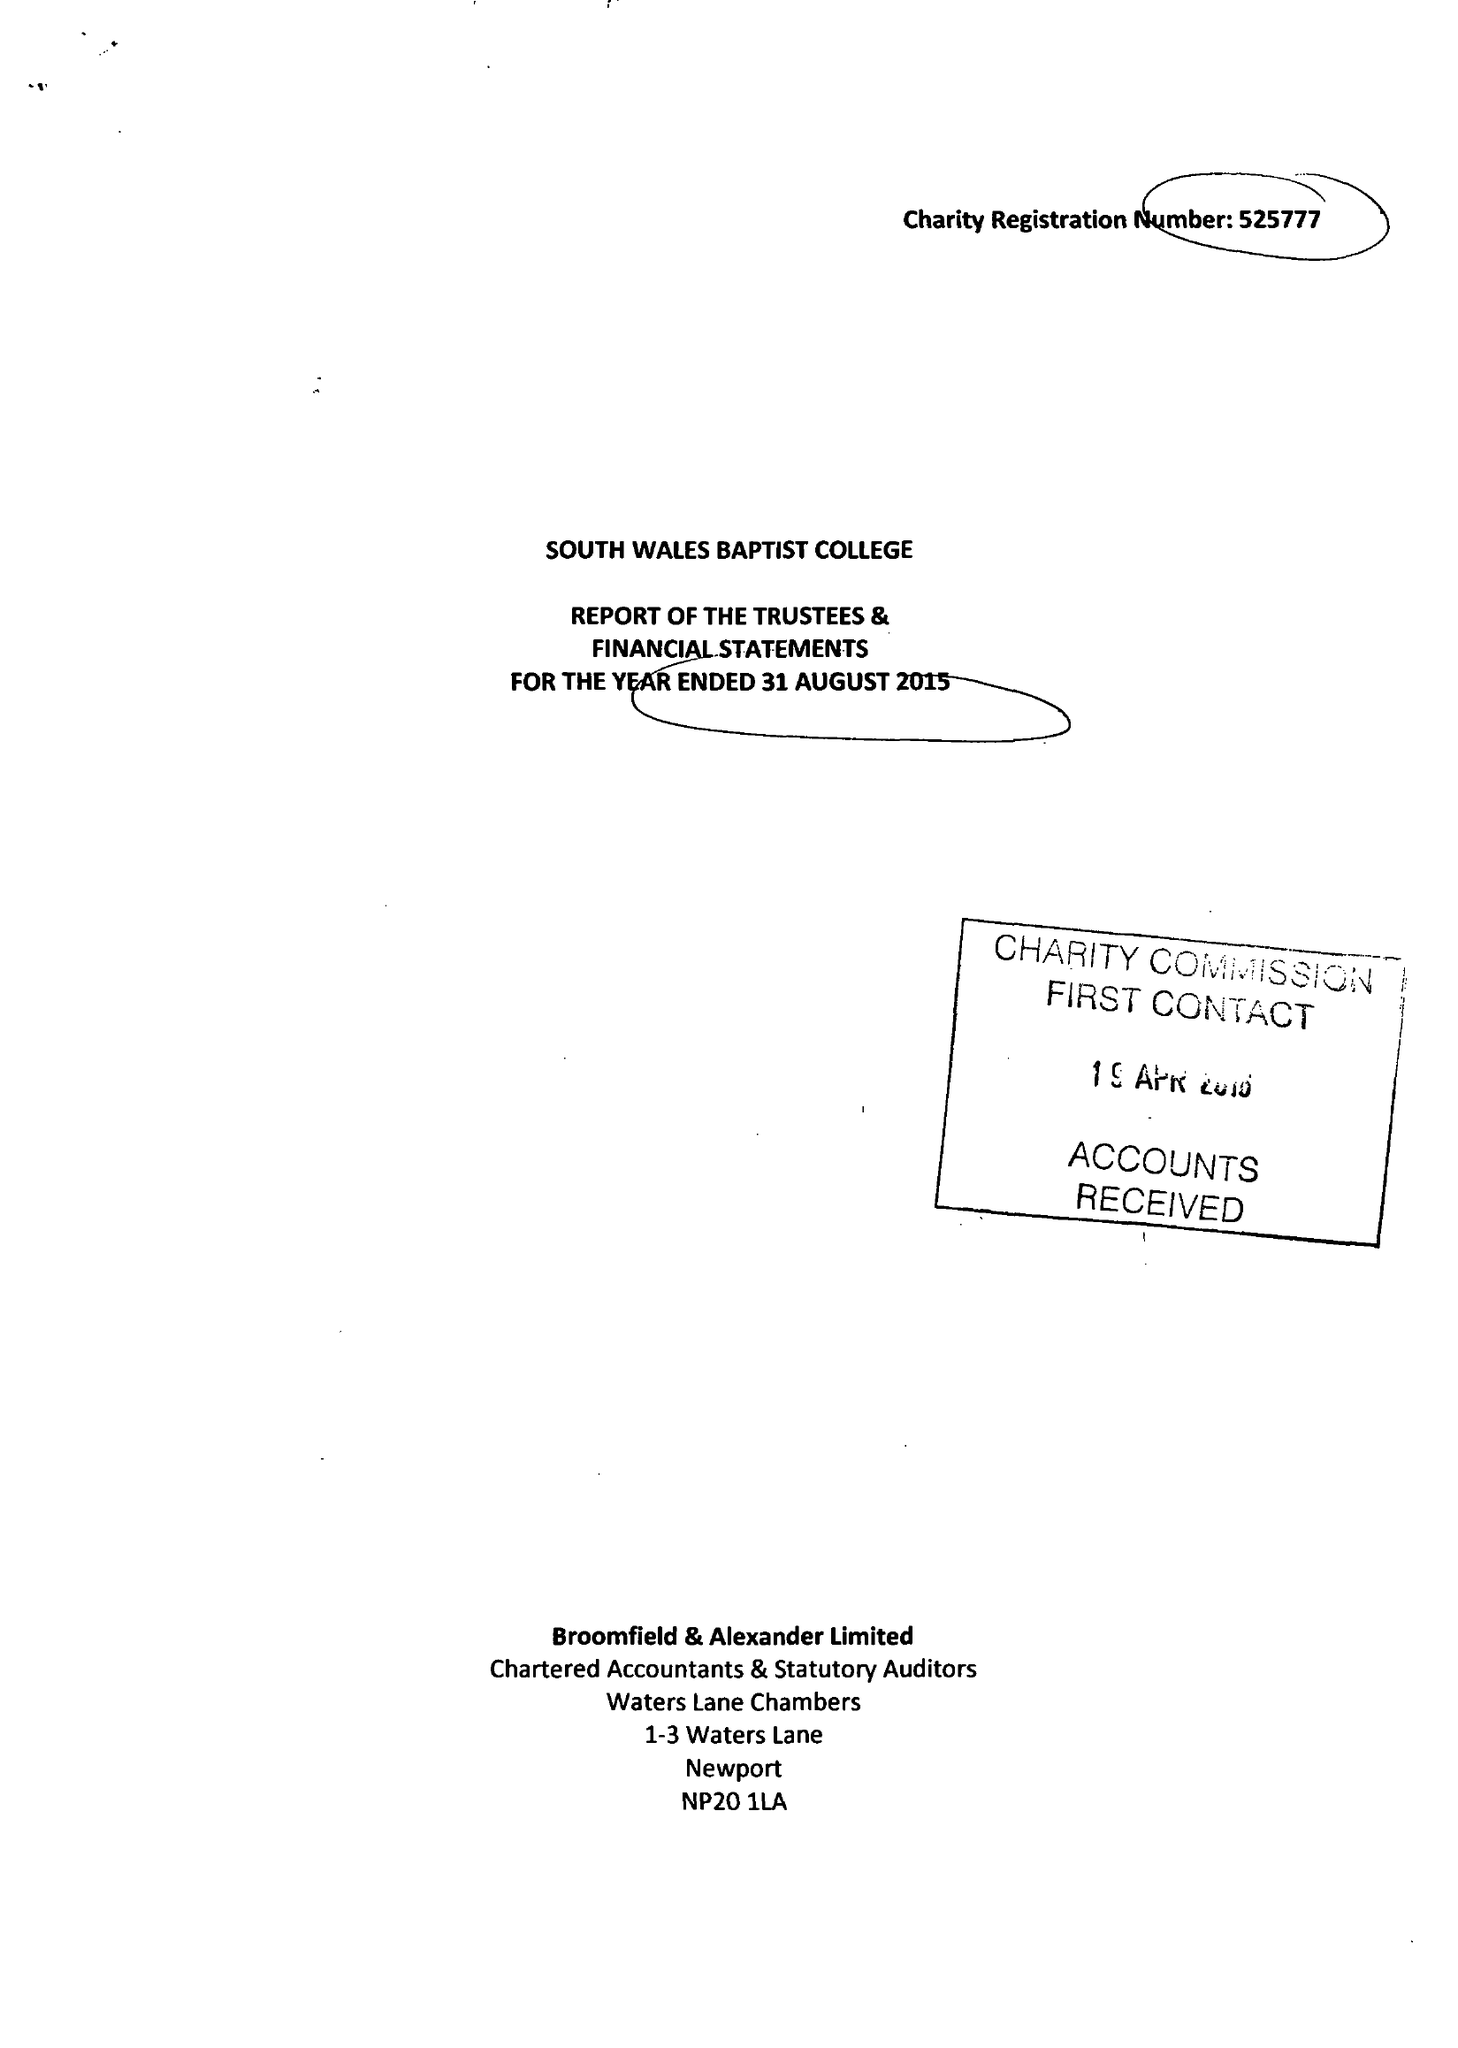What is the value for the address__post_town?
Answer the question using a single word or phrase. CARDIFF 